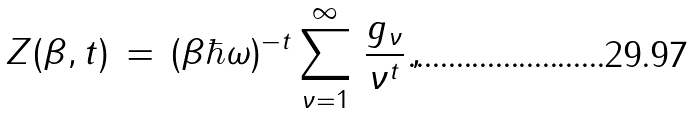Convert formula to latex. <formula><loc_0><loc_0><loc_500><loc_500>Z ( \beta , t ) \, = \, ( \beta \hbar { \omega } ) ^ { - t } \sum _ { \nu = 1 } ^ { \infty } \, \frac { g _ { \nu } } { \nu ^ { t } } \, ,</formula> 